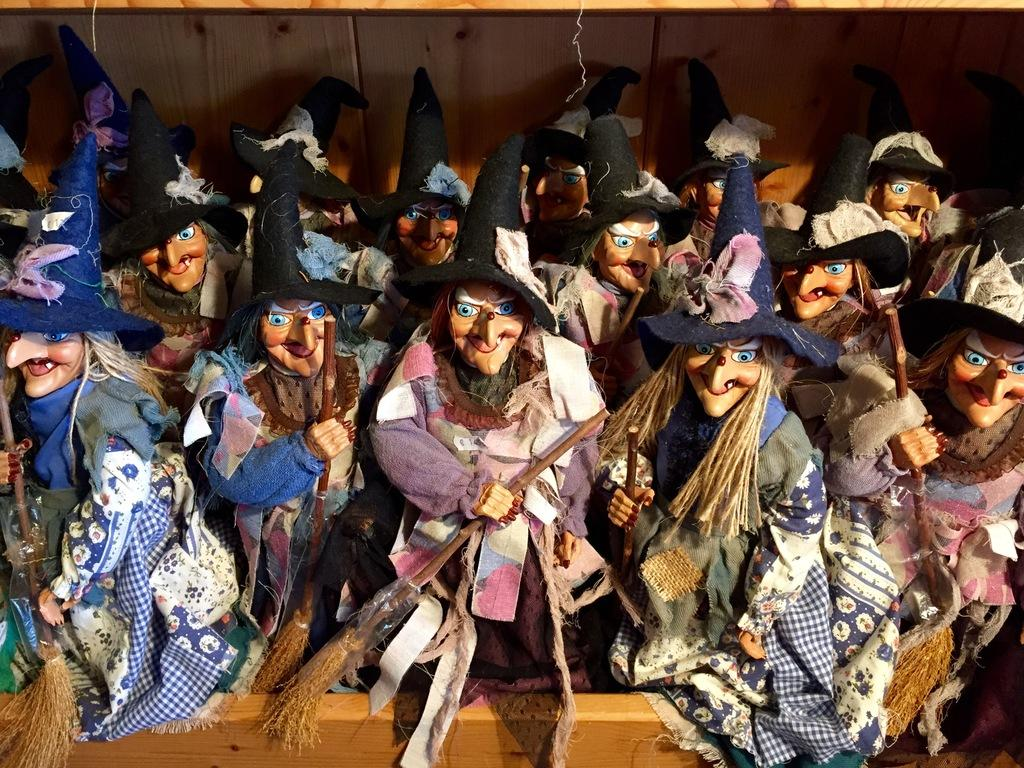What type of dolls are in the image? There are witch dolls in the image. Where are the dolls located? The dolls are on a table. What accessories do the dolls have? Each doll has a hat and is carrying a broom in its hand. Is the silk used to make the dolls' hats in the image? There is no mention of silk being used to make the dolls' hats in the image. 